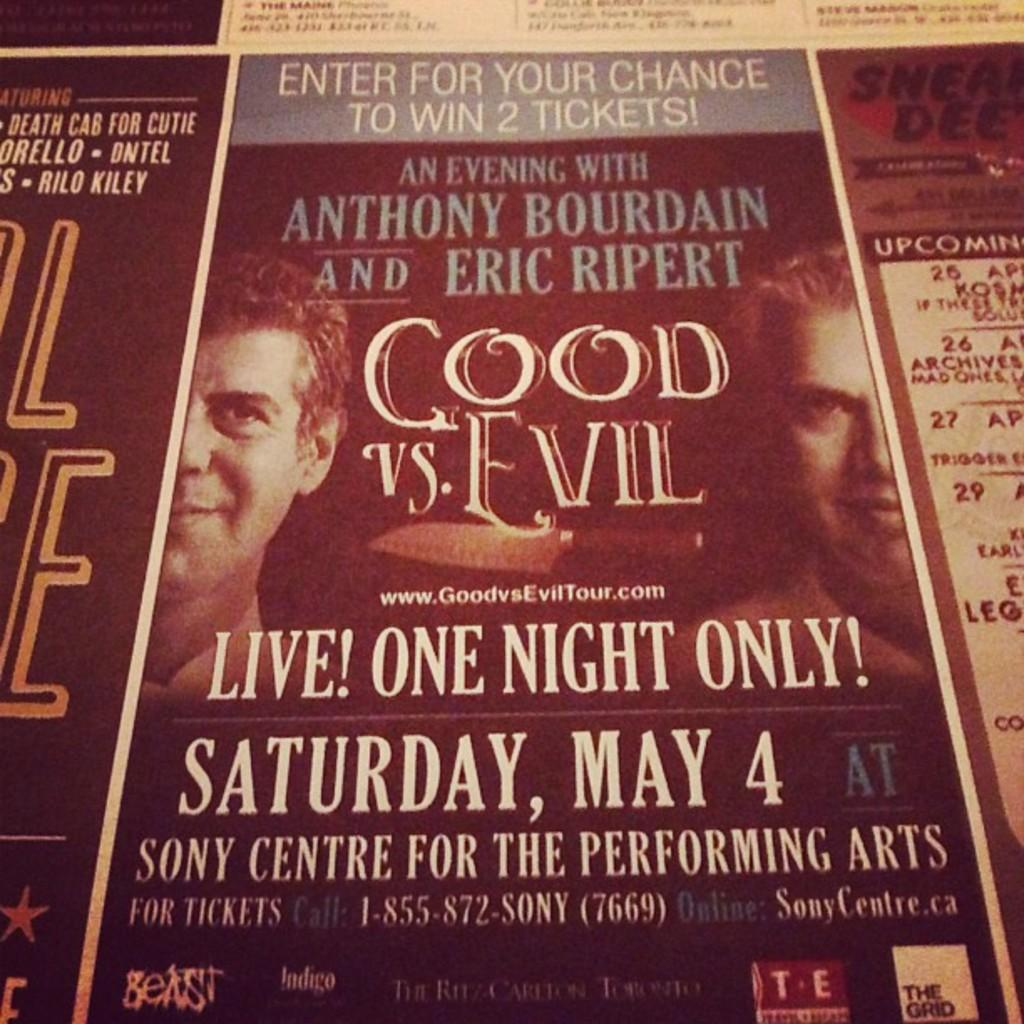<image>
Relay a brief, clear account of the picture shown. Live one night only poster with Anthony Bourdain and Eric Ripert 